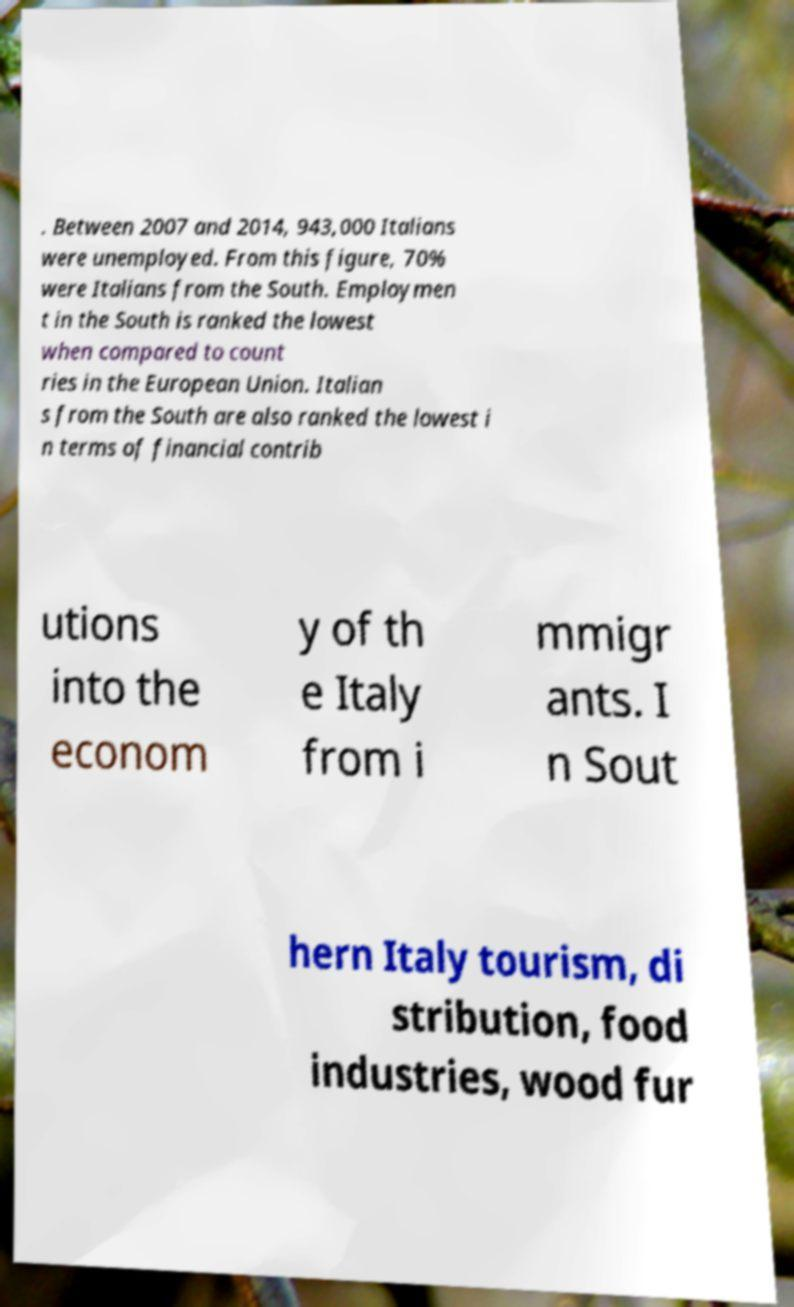Can you accurately transcribe the text from the provided image for me? . Between 2007 and 2014, 943,000 Italians were unemployed. From this figure, 70% were Italians from the South. Employmen t in the South is ranked the lowest when compared to count ries in the European Union. Italian s from the South are also ranked the lowest i n terms of financial contrib utions into the econom y of th e Italy from i mmigr ants. I n Sout hern Italy tourism, di stribution, food industries, wood fur 